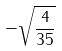Convert formula to latex. <formula><loc_0><loc_0><loc_500><loc_500>- \sqrt { \frac { 4 } { 3 5 } }</formula> 